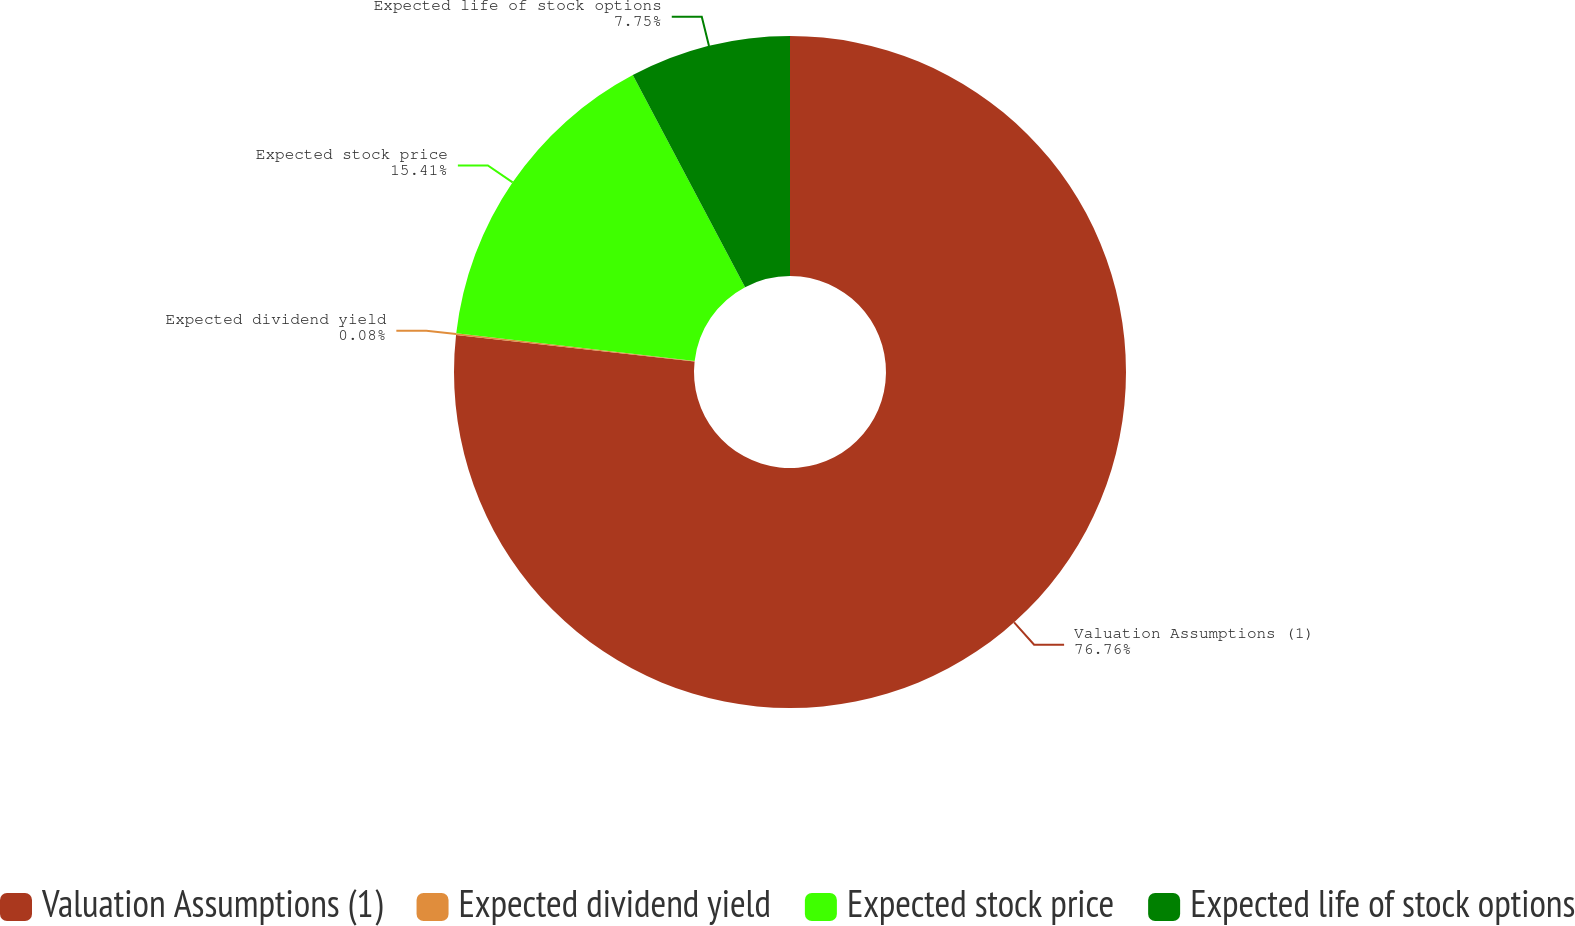<chart> <loc_0><loc_0><loc_500><loc_500><pie_chart><fcel>Valuation Assumptions (1)<fcel>Expected dividend yield<fcel>Expected stock price<fcel>Expected life of stock options<nl><fcel>76.76%<fcel>0.08%<fcel>15.41%<fcel>7.75%<nl></chart> 